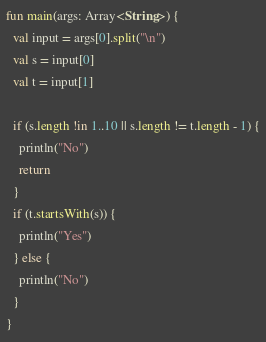Convert code to text. <code><loc_0><loc_0><loc_500><loc_500><_Kotlin_>fun main(args: Array<String>) {
  val input = args[0].split("\n")
  val s = input[0]
  val t = input[1]
  
  if (s.length !in 1..10 || s.length != t.length - 1) {
    println("No")
    return
  }
  if (t.startsWith(s)) {
    println("Yes")    
  } else {
    println("No")    
  }
}</code> 